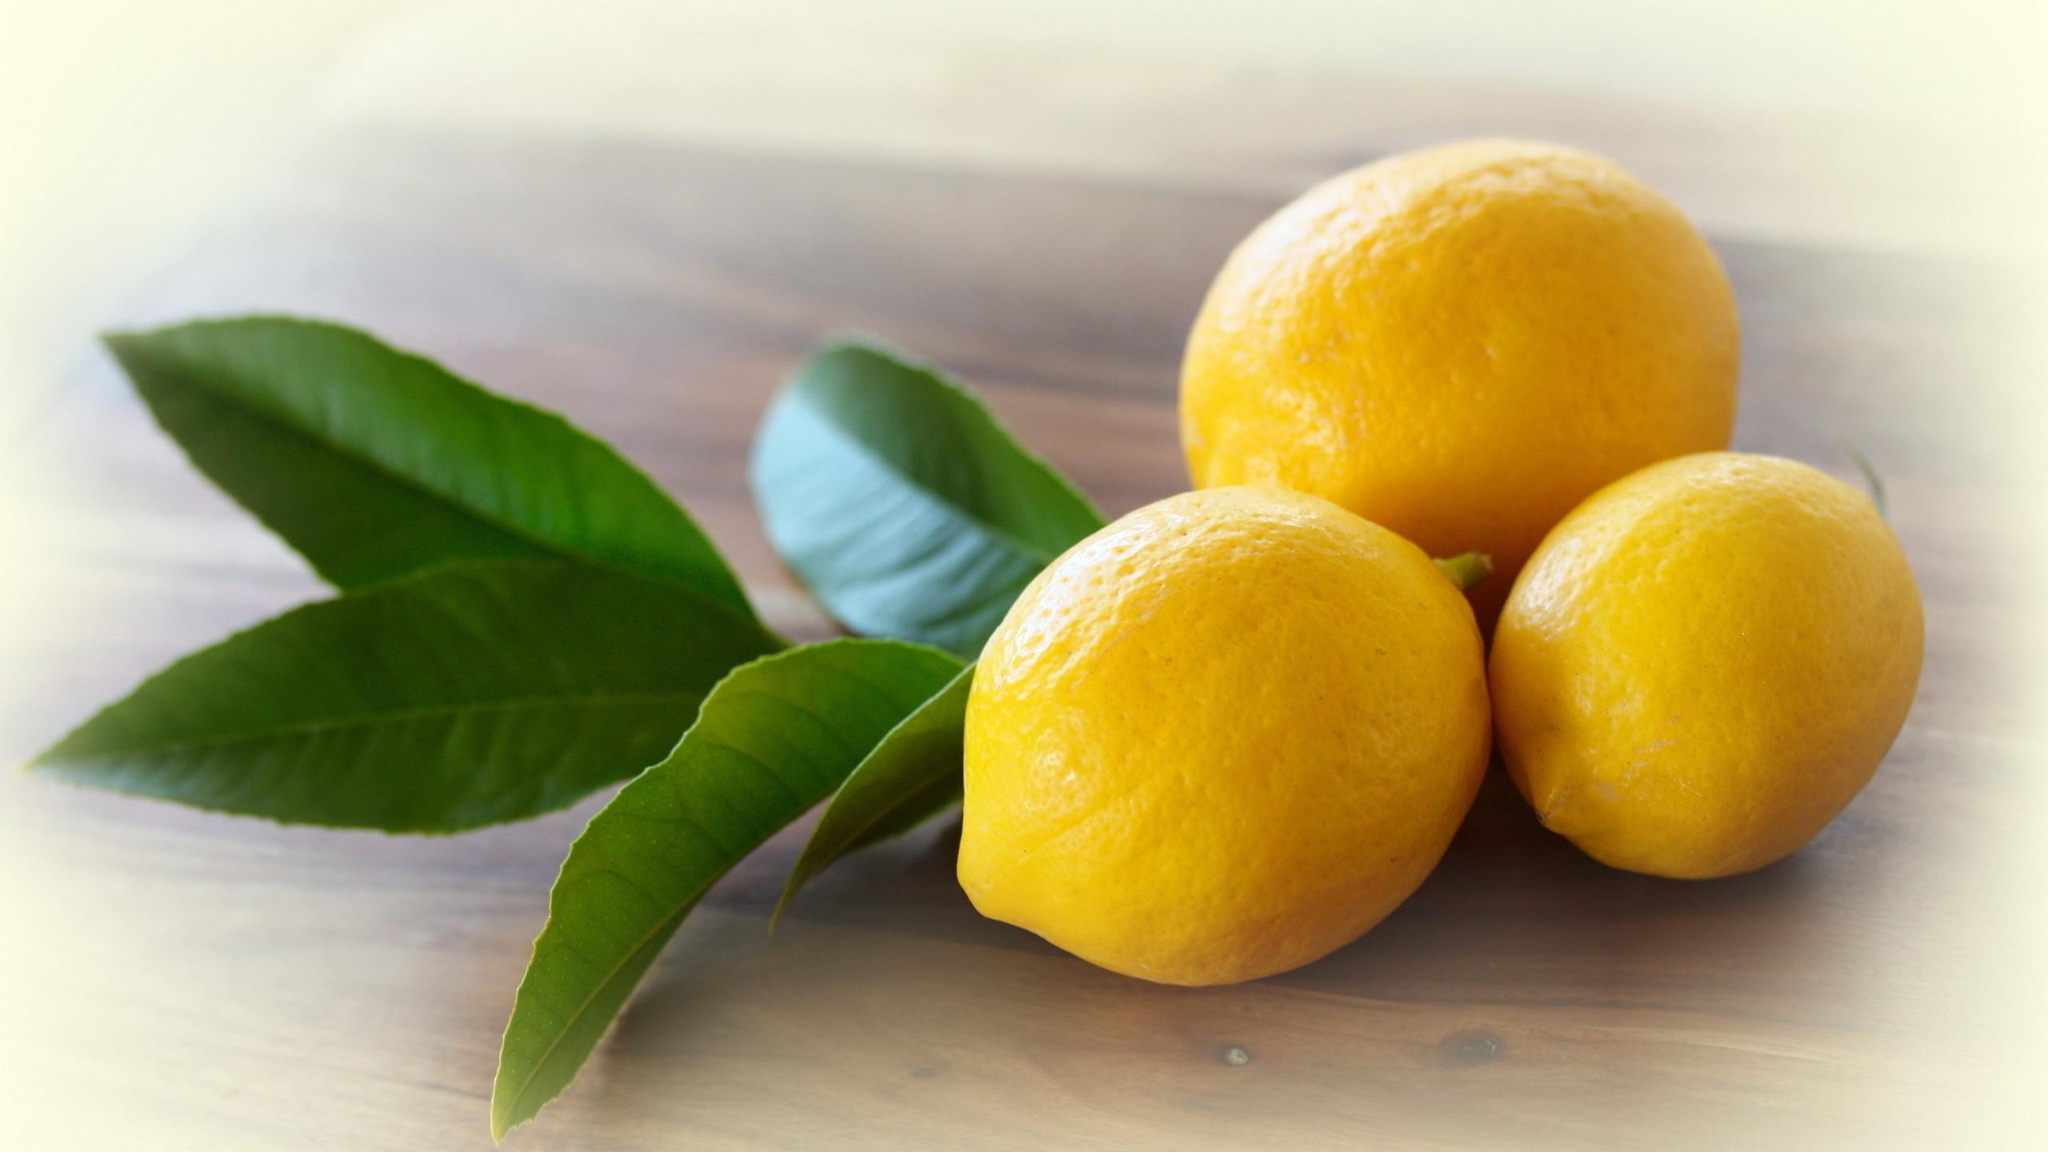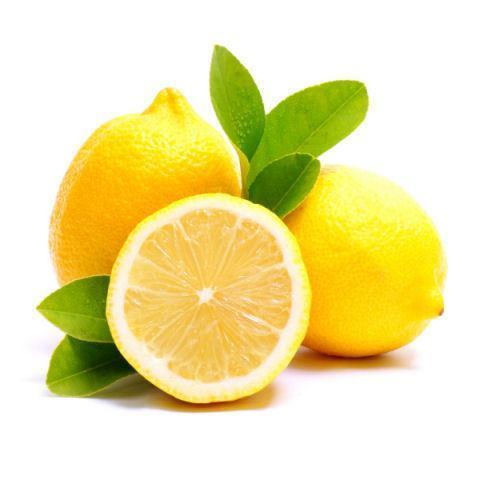The first image is the image on the left, the second image is the image on the right. Evaluate the accuracy of this statement regarding the images: "Exactly one of the images of lemons includes leaves.". Is it true? Answer yes or no. No. The first image is the image on the left, the second image is the image on the right. Evaluate the accuracy of this statement regarding the images: "In at least one image, there are three yellow lemons with at single stock of leaves next to the lemon on the left side.". Is it true? Answer yes or no. Yes. 